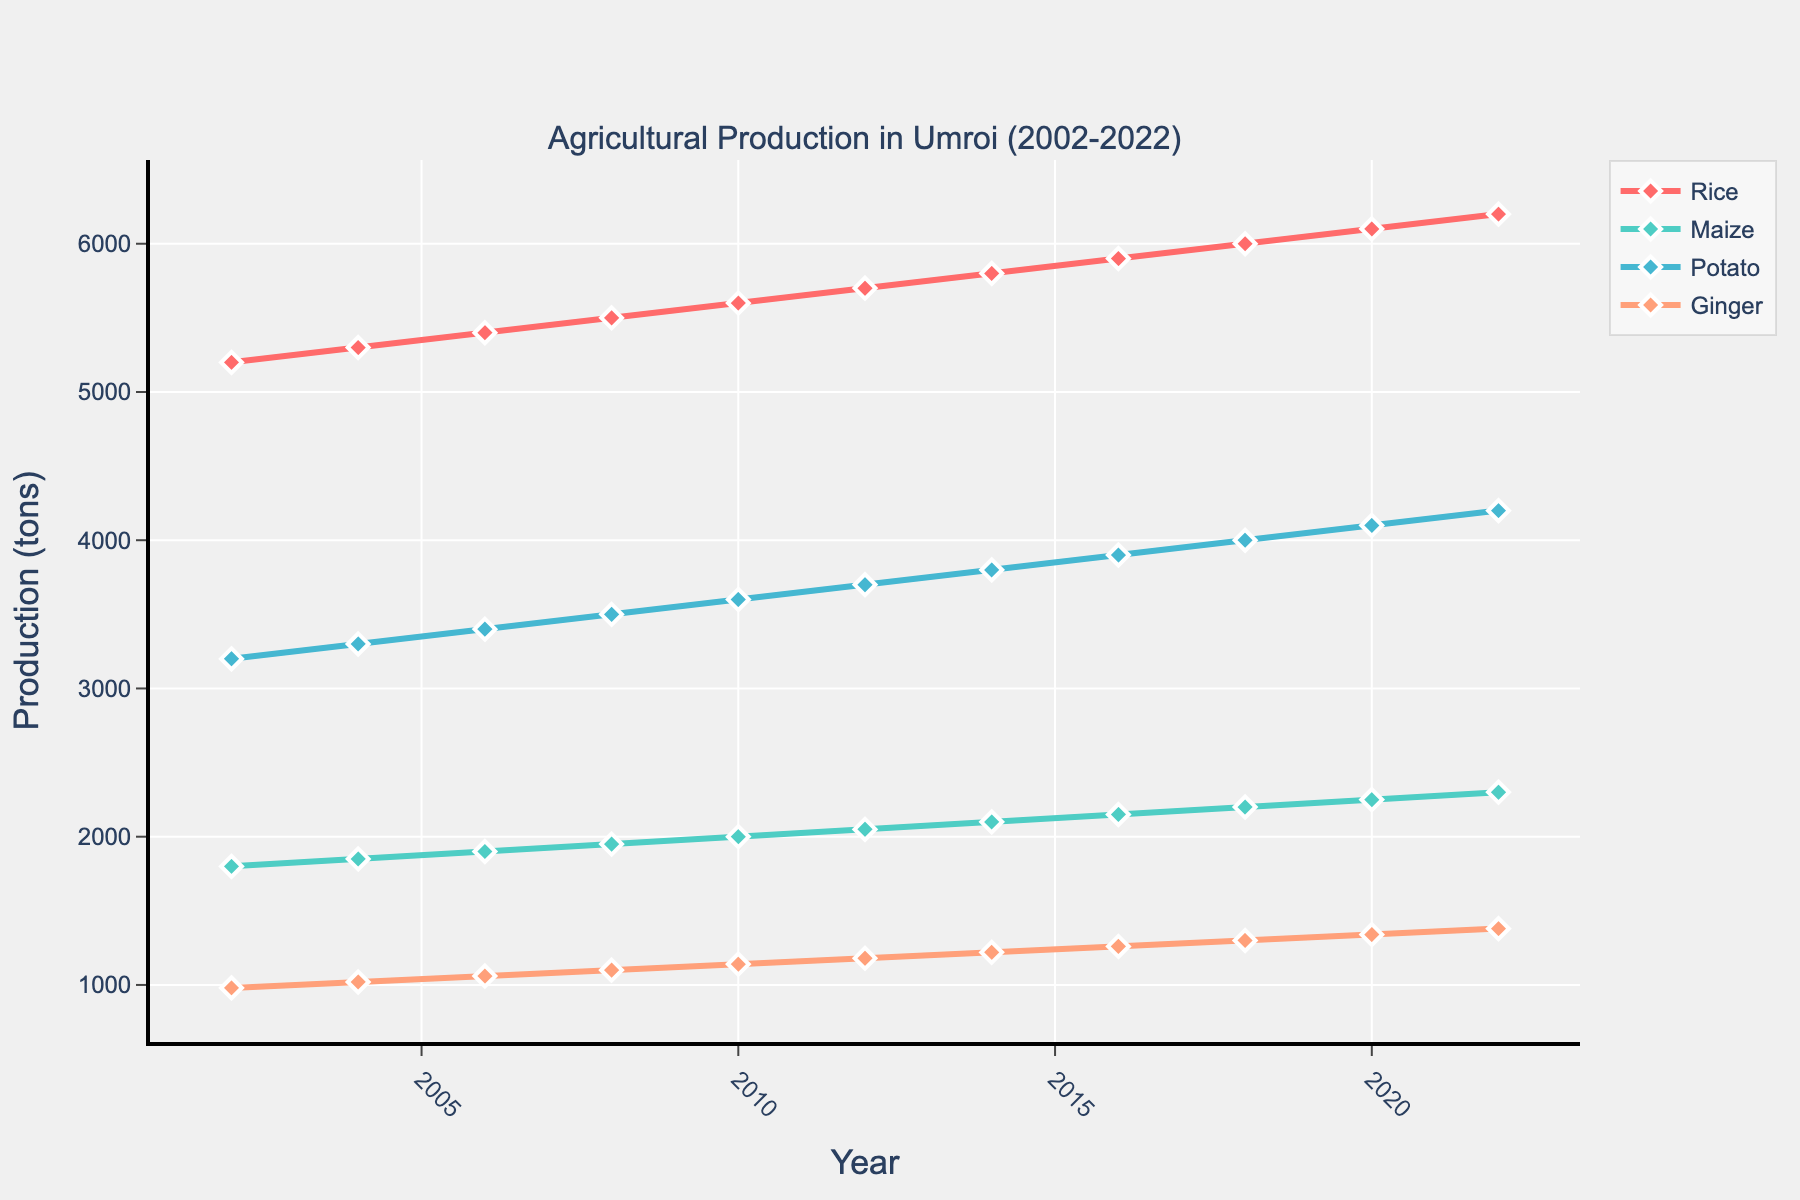What is the general trend in rice production over the last 20 years? From the line chart, we can see that the production of rice has steadily increased from 5,200 tons in 2002 to 6,200 tons in 2022. The upward slope of the line indicates a general increasing trend.
Answer: Increasing Which crop had the highest production increase between 2002 and 2022? By comparing the difference in production from 2002 to 2022 for each crop, we get: Rice: 1,000 tons; Maize: 500 tons; Potato: 1,000 tons; Ginger: 400 tons. Both Rice and Potato have the highest increase of 1,000 tons.
Answer: Rice and Potato In 2022, which crop had the lowest production, and what was it? By visually inspecting the endpoints for each line in 2022, we can see that Ginger has the lowest production, which is 1,380 tons.
Answer: Ginger; 1,380 tons How many tons of maize were produced in 2010? From the graph, we locate the point for maize in the year 2010 and observe that its production was 2,000 tons.
Answer: 2,000 tons How did the production of ginger change from 2008 to 2018? From the graph, Ginger production in 2008 was 1,100 tons and increased to 1,300 tons in 2018. The change in production is 1,300 - 1,100 = 200 tons.
Answer: Increased by 200 tons How many total tons of all crops were produced in 2022? Summing up the production values for Rice (6,200), Maize (2,300), Potato (4,200), and Ginger (1,380) in 2022, we get 6,200 + 2,300 + 4,200 + 1,380 = 14,080 tons.
Answer: 14,080 tons Which crop shows a consistent increase in production without any plateau over the observed years? By examining the lines on the graph, we can see that all crop productions show a consistent increase, but if we need to state one explicitly, Rice maintains a steady upward trend without any observable plateau.
Answer: Rice What is the average annual increase in potato production over the 20 years? The production of potatoes increased from 3,200 tons in 2002 to 4,200 tons in 2022, a difference of 1,000 tons over 20 years. The average annual increase is 1,000 tons / 20 years = 50 tons per year.
Answer: 50 tons per year Which crop's production showed the least variability over the years? By observing the slope of the lines, Ginger has the least increase, indicating the least variability in production compared to the other crops which have steeper slopes.
Answer: Ginger In which year did the Maize production first exceed 2000 tons? By analyzing the Maize production trend line, it can be observed that it first exceeded 2,000 tons in the year 2010.
Answer: 2010 